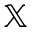<formula> <loc_0><loc_0><loc_500><loc_500>\mathbb { X }</formula> 